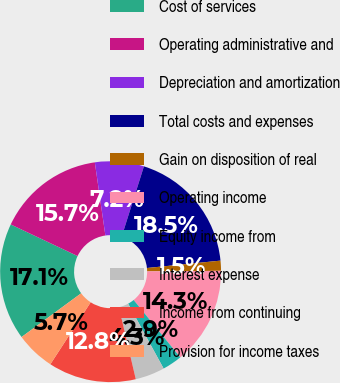Convert chart to OTSL. <chart><loc_0><loc_0><loc_500><loc_500><pie_chart><fcel>Cost of services<fcel>Operating administrative and<fcel>Depreciation and amortization<fcel>Total costs and expenses<fcel>Gain on disposition of real<fcel>Operating income<fcel>Equity income from<fcel>Interest expense<fcel>Income from continuing<fcel>Provision for income taxes<nl><fcel>17.11%<fcel>15.69%<fcel>7.16%<fcel>18.53%<fcel>1.47%<fcel>14.26%<fcel>2.89%<fcel>4.31%<fcel>12.84%<fcel>5.74%<nl></chart> 